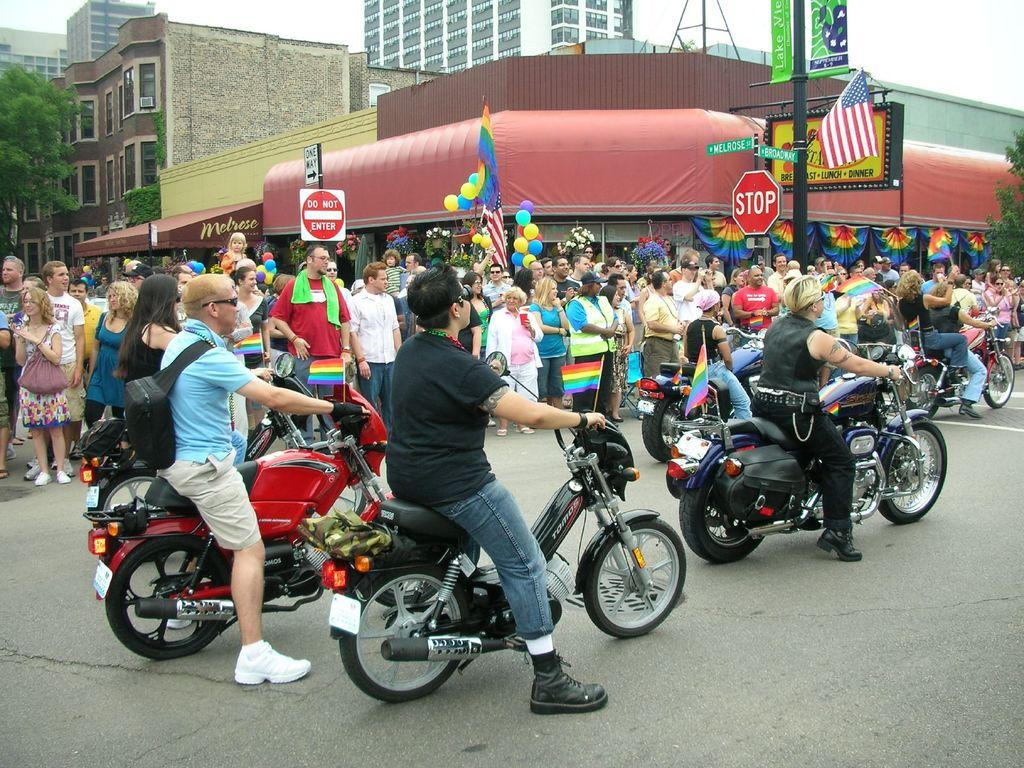What are the people in the image doing? There is a group of people standing, and there are persons sitting on a bike and riding it. What type of setting is depicted in the image? The image depicts a road with buildings, a tree, a pole, a flag, boards, and balloons visible. How many people are riding the bike in the image? There is only one person sitting on the bike and riding it. What type of friction is present between the bike and the road in the image? The image does not provide information about the type of friction between the bike and the road. Can you tell me how many porters are assisting the people in the image? There is no mention of porters in the image; the people are either standing or riding the bike. How is the division of the road depicted in the image? The image does not show any specific division of the road; it simply depicts a road with various elements visible. 